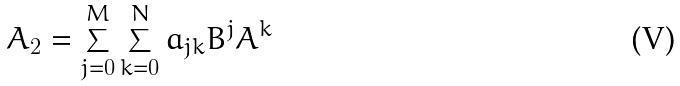<formula> <loc_0><loc_0><loc_500><loc_500>A _ { 2 } = \sum _ { j = 0 } ^ { M } \sum _ { k = 0 } ^ { N } a _ { j k } B ^ { j } A ^ { k }</formula> 